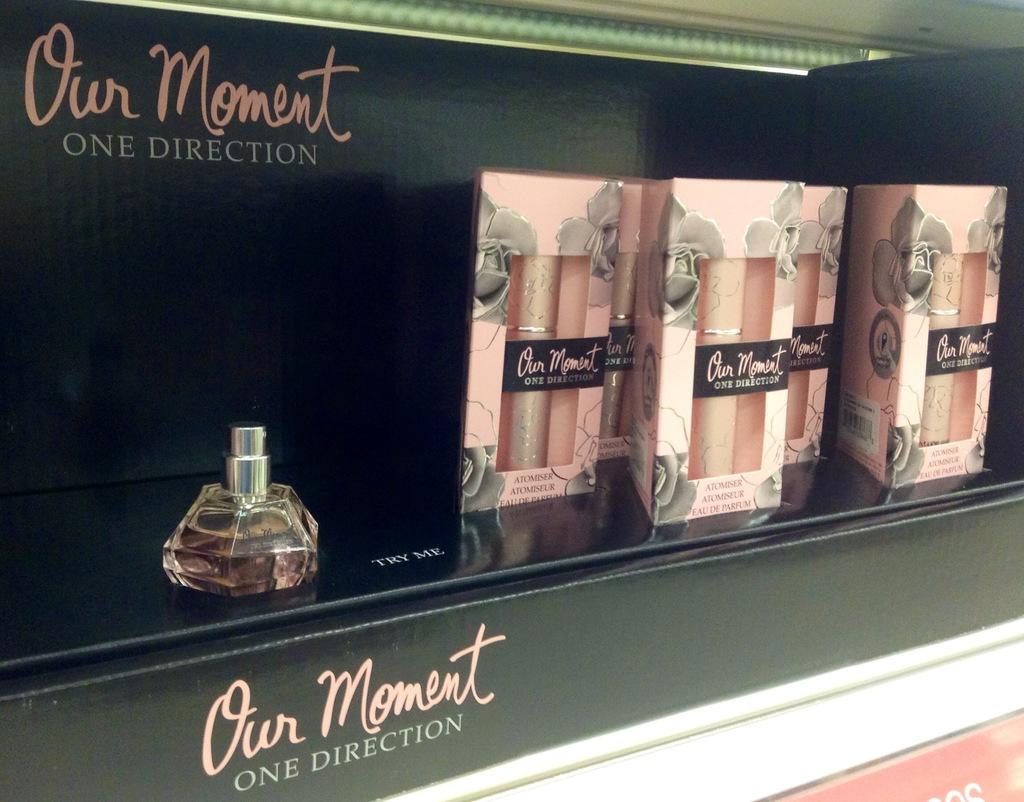<image>
Create a compact narrative representing the image presented. some cologne near a message that says our moment 